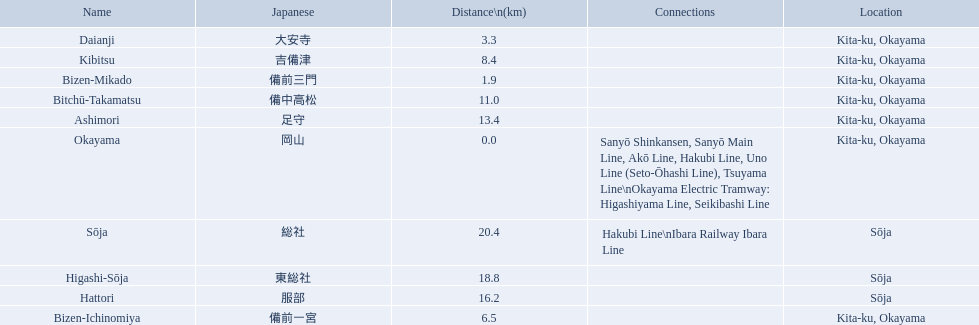What are all of the train names? Okayama, Bizen-Mikado, Daianji, Bizen-Ichinomiya, Kibitsu, Bitchū-Takamatsu, Ashimori, Hattori, Higashi-Sōja, Sōja. What is the distance for each? 0.0, 1.9, 3.3, 6.5, 8.4, 11.0, 13.4, 16.2, 18.8, 20.4. And which train's distance is between 1 and 2 km? Bizen-Mikado. What are the members of the kibi line? Okayama, Bizen-Mikado, Daianji, Bizen-Ichinomiya, Kibitsu, Bitchū-Takamatsu, Ashimori, Hattori, Higashi-Sōja, Sōja. Which of them have a distance of more than 1 km? Bizen-Mikado, Daianji, Bizen-Ichinomiya, Kibitsu, Bitchū-Takamatsu, Ashimori, Hattori, Higashi-Sōja, Sōja. Which of them have a distance of less than 2 km? Okayama, Bizen-Mikado. Which has a distance between 1 km and 2 km? Bizen-Mikado. 